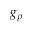Convert formula to latex. <formula><loc_0><loc_0><loc_500><loc_500>g _ { \rho }</formula> 